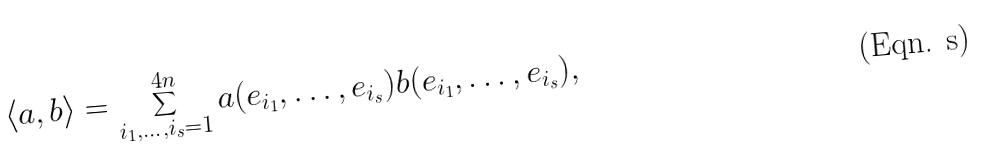<formula> <loc_0><loc_0><loc_500><loc_500>\langle a , b \rangle = \sum _ { i _ { 1 } , \dots , i _ { s } = 1 } ^ { 4 n } a ( e _ { i _ { 1 } } , \dots , e _ { i _ { s } } ) b ( e _ { i _ { 1 } } , \dots , e _ { i _ { s } } ) ,</formula> 